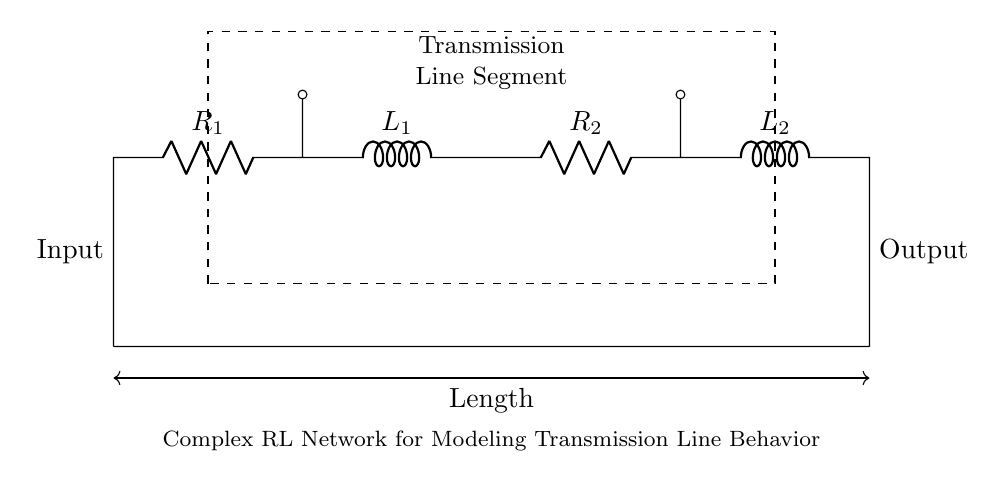What are the two types of components in this circuit? The circuit contains resistors and inductors, specifically labeled as R1, R2 and L1, L2.
Answer: Resistors and inductors What is the total number of components in this network? The network includes four components: two resistors (R1 and R2) and two inductors (L1 and L2).
Answer: Four What do the dashed lines represent in this circuit? The dashed lines and rectangle indicate the segment designated for transmission line modeling, denoting a specific operational section of the circuit.
Answer: Transmission line segment How is the input connected in this circuit? The input is connected on the left side of the circuit diagram, at the point labeled 'Input', which connects to the first resistor R1.
Answer: Input on the left What is the significance of the arrows pointing out of the circuit? The arrows indicate input and output connections to the external circuit, showing the flow direction of signals or currents entering and exiting the transmission line segment.
Answer: Input and output connections What is the purpose of using both resistors and inductors in this circuit? The use of both resistors and inductors allows for modeling complex behavior of transmission lines, such as resistive and reactive (inductive) characteristics affecting the voltage and current waveforms.
Answer: Modeling transmission line behavior What kind of network does this circuit exemplify? This circuit exemplifies a complex RL network, focusing on both resistive and inductive elements to simulate transmission line effects like impedance and phase shift.
Answer: Complex RL network 